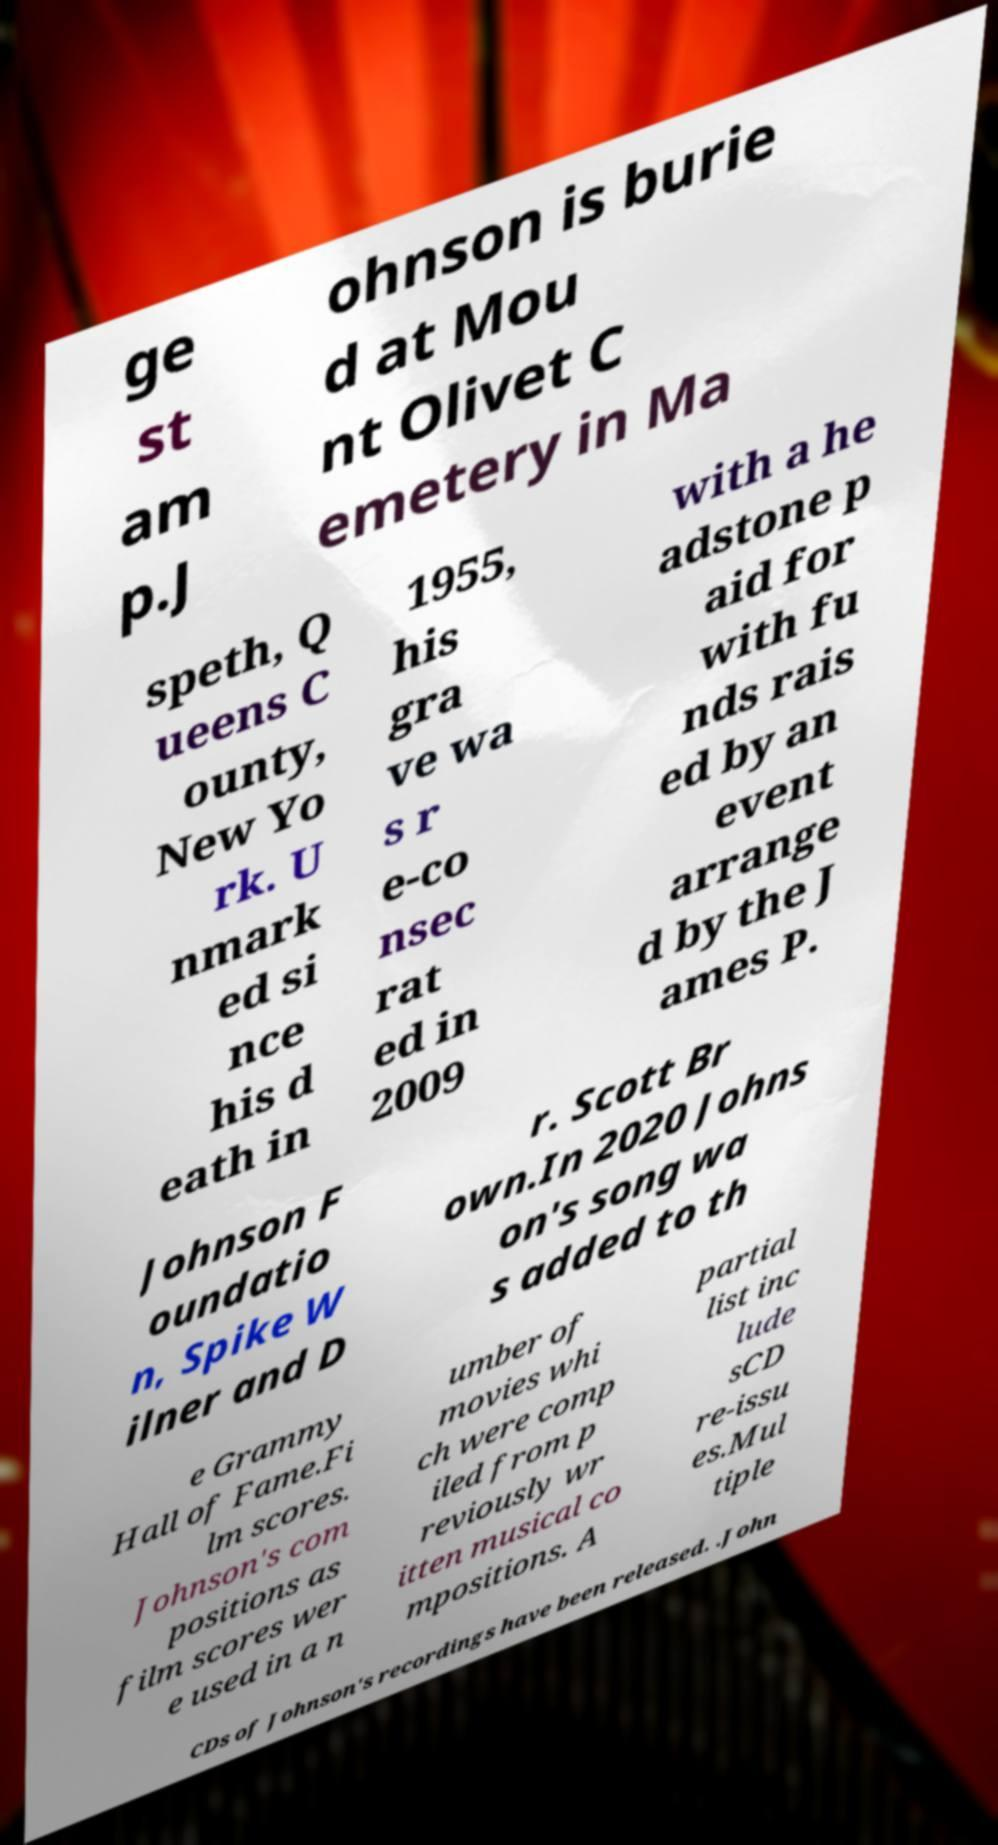Please read and relay the text visible in this image. What does it say? ge st am p.J ohnson is burie d at Mou nt Olivet C emetery in Ma speth, Q ueens C ounty, New Yo rk. U nmark ed si nce his d eath in 1955, his gra ve wa s r e-co nsec rat ed in 2009 with a he adstone p aid for with fu nds rais ed by an event arrange d by the J ames P. Johnson F oundatio n, Spike W ilner and D r. Scott Br own.In 2020 Johns on's song wa s added to th e Grammy Hall of Fame.Fi lm scores. Johnson's com positions as film scores wer e used in a n umber of movies whi ch were comp iled from p reviously wr itten musical co mpositions. A partial list inc lude sCD re-issu es.Mul tiple CDs of Johnson's recordings have been released. .John 